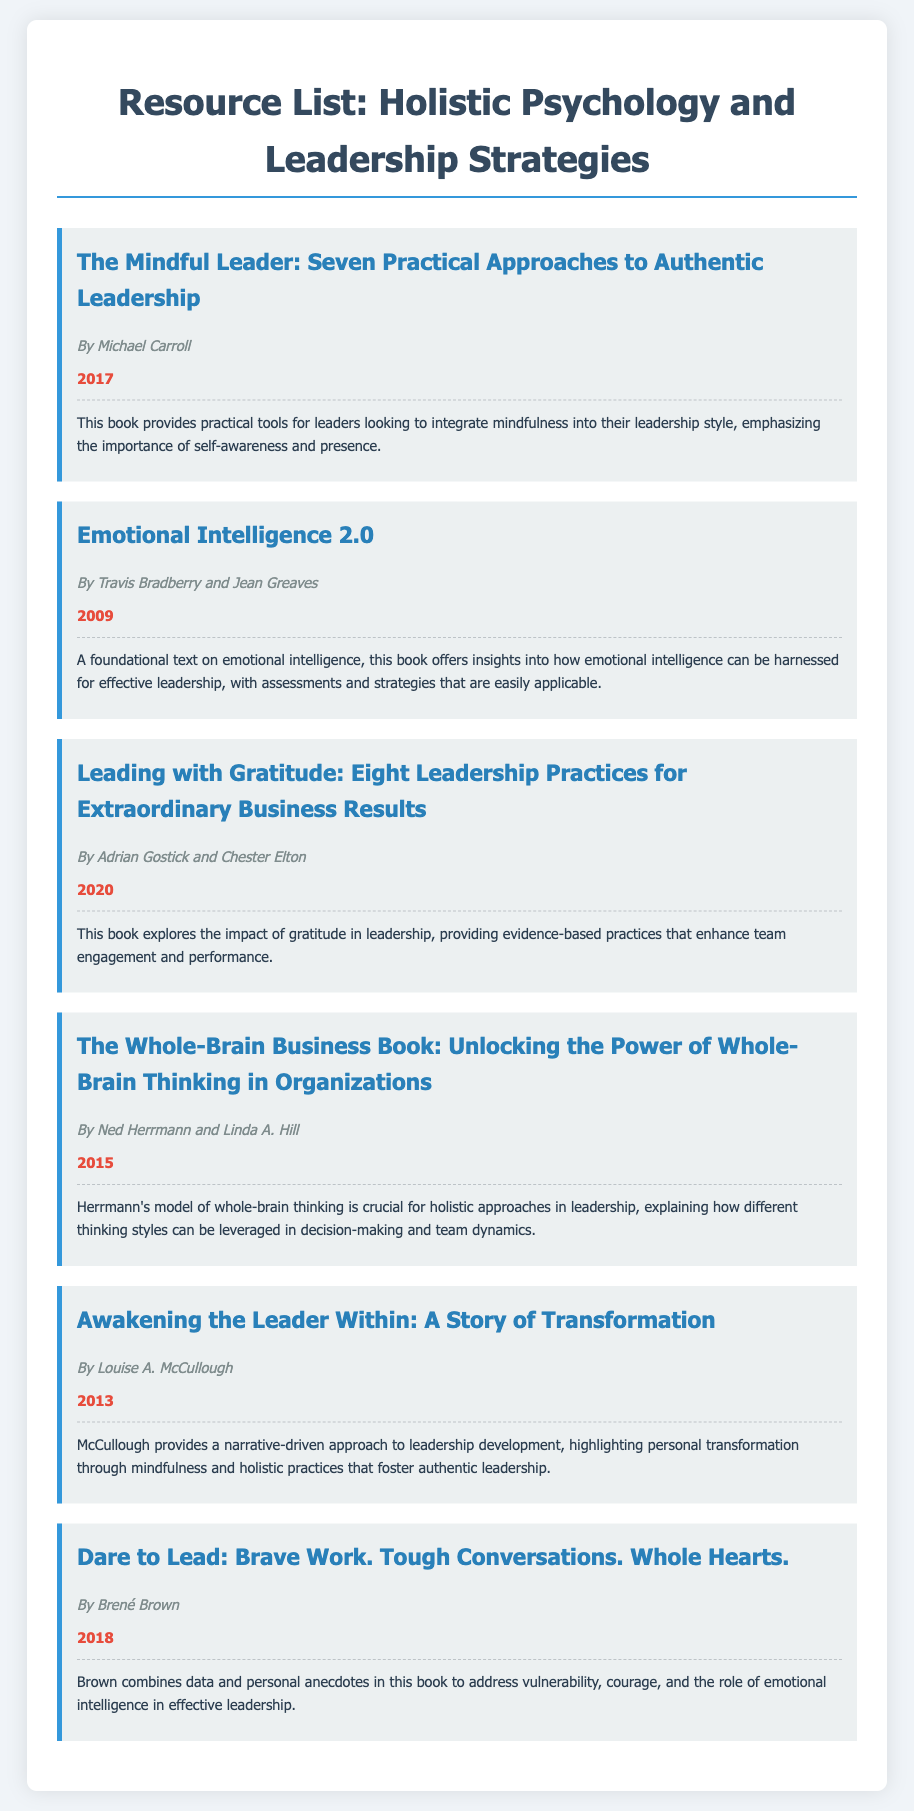what is the title of the first resource listed? The title of the first resource is presented in the document, which is "The Mindful Leader: Seven Practical Approaches to Authentic Leadership."
Answer: The Mindful Leader: Seven Practical Approaches to Authentic Leadership who authored "Dare to Lead"? The author of "Dare to Lead" is mentioned in the document, which identifies Brené Brown as the author.
Answer: Brené Brown what year was "Emotional Intelligence 2.0" published? The publication year of "Emotional Intelligence 2.0" is specified as 2009 in the document.
Answer: 2009 which resource emphasizes gratitude in leadership? The document identifies the resource that focuses on gratitude as "Leading with Gratitude: Eight Leadership Practices for Extraordinary Business Results."
Answer: Leading with Gratitude: Eight Leadership Practices for Extraordinary Business Results how many publications in total are listed? The total number of publications is based on the number of resources shown in the document, which includes six entries.
Answer: 6 which author is associated with the concept of whole-brain thinking? The document states that Ned Herrmann and Linda A. Hill are associated with the concept of whole-brain thinking in the resource titled "The Whole-Brain Business Book."
Answer: Ned Herrmann and Linda A. Hill 